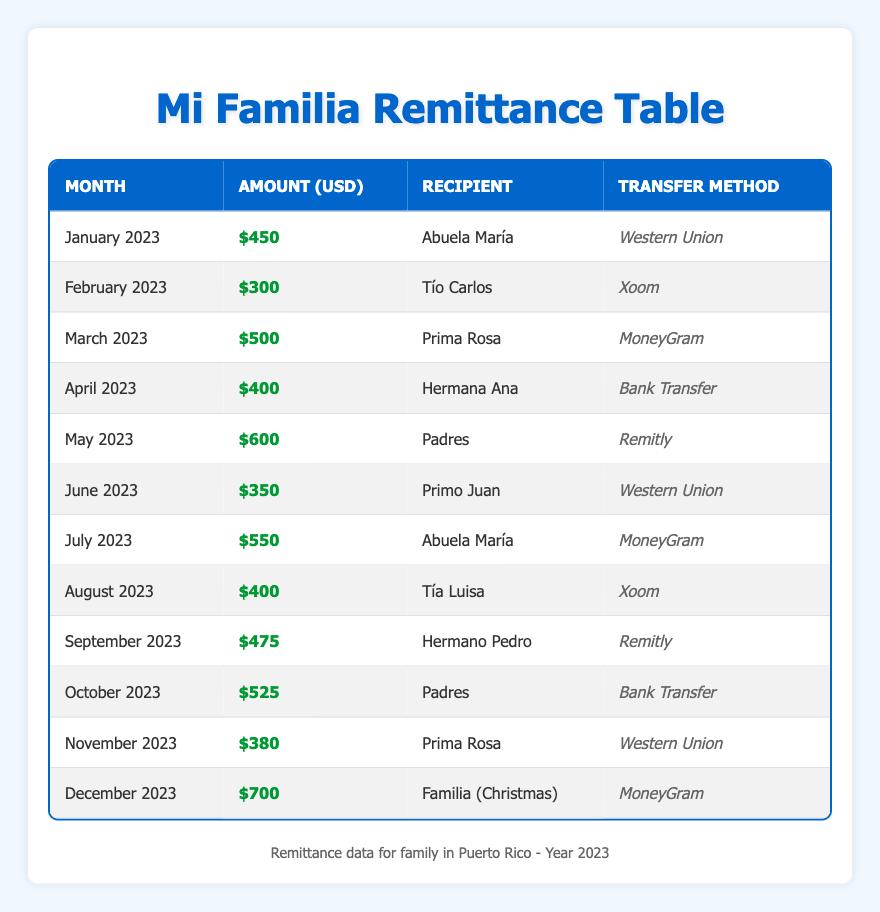What was the highest amount sent in a month? From the table, I identify the amounts sent each month. The maximum amount recorded is $700 sent in December 2023.
Answer: $700 How much was sent to Abuela María in total? I look for the entries related to Abuela María. She received $450 in January and $550 in July. Adding these amounts together gives $450 + $550 = $1000.
Answer: $1000 Which transfer method was used most frequently? I will count the occurrences of each transfer method in the table. Western Union appears 4 times, MoneyGram 3 times, Xoom 2 times, and Bank Transfer and Remitly each occur 2 times. The most frequent method is Western Union.
Answer: Western Union What was the average monthly remittance amount sent over the year? I will sum all the monthly amounts: $450 + $300 + $500 + $400 + $600 + $350 + $550 + $400 + $475 + $525 + $380 + $700 = $5,575. There are 12 months, so I divide $5,575 by 12, yielding an average of approximately $464.58.
Answer: $464.58 Did I send more money in the second half of the year than in the first half? First, I calculate the total for the first half: $450 + $300 + $500 + $400 + $600 + $350 = $2,600. For the second half, I sum $550 + $400 + $475 + $525 + $380 + $700 = $3,080. Since $3,080 is greater than $2,600, I confirm that more was sent in the second half.
Answer: Yes What was the total amount sent to Padres? I identify both entries for Padres: $600 sent in May and $525 sent in October. Adding these amounts gives $600 + $525 = $1,125.
Answer: $1,125 Was money sent in every month of the year? By checking the table, I see that there are entries for each month from January to December, confirming that remittances were sent every month.
Answer: Yes Which recipient received the least amount? I review the amounts for each recipient: Abuela María ($450, $550), Tío Carlos ($300), Prima Rosa ($500, $380), Hermana Ana ($400), Padres ($600, $525), Primo Juan ($350), Tía Luisa ($400), and Hermano Pedro ($475). The least amount is $300 sent to Tío Carlos.
Answer: Tío Carlos 